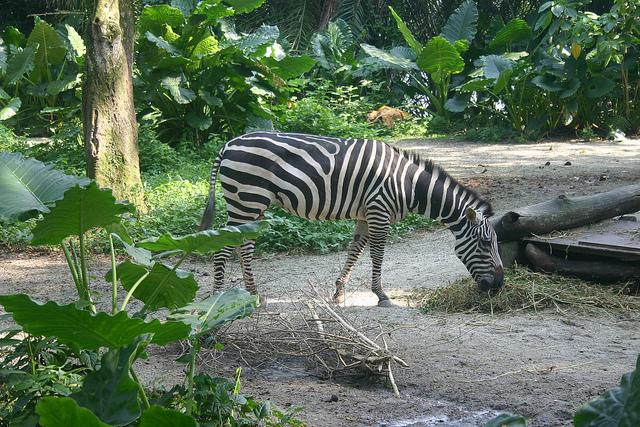How many zebras are shown?
Short answer required. 1. Why is the zebra doing what it is doing?
Keep it brief. Eating. Are there trees behind the zebra?
Write a very short answer. Yes. How many zebras can you see?
Quick response, please. 1. What color is the zebra?
Keep it brief. Black and white. What kind of tree did that log come from?
Concise answer only. Bamboo. 